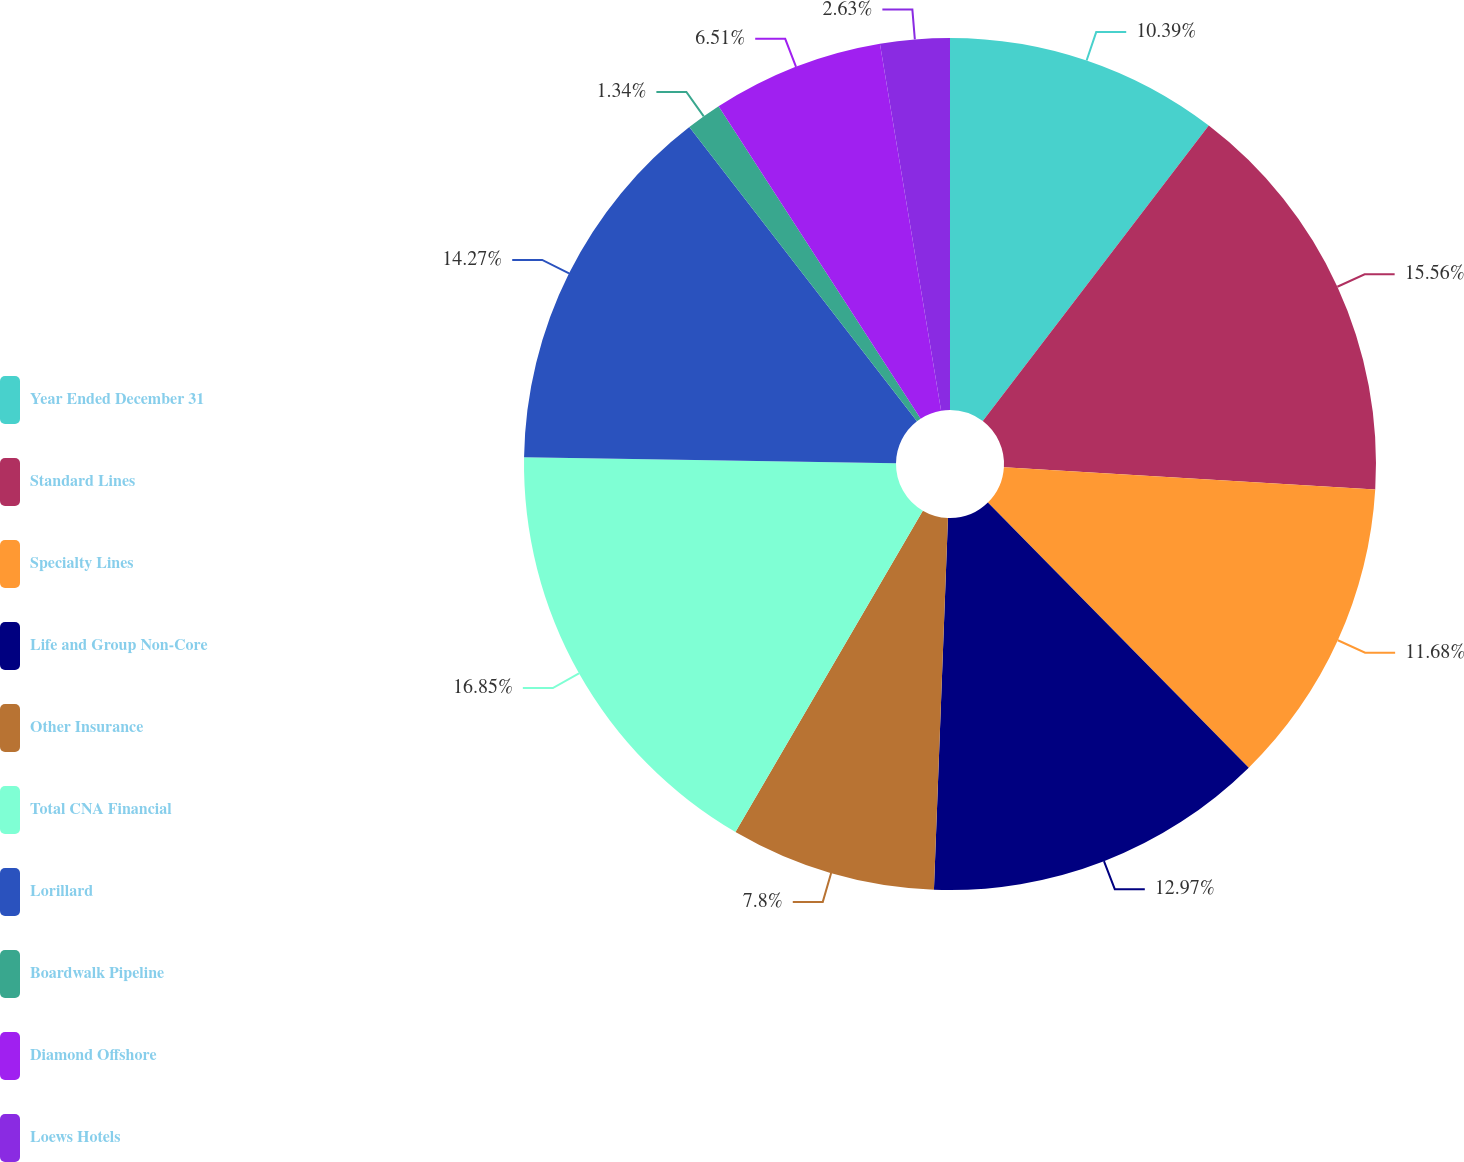Convert chart to OTSL. <chart><loc_0><loc_0><loc_500><loc_500><pie_chart><fcel>Year Ended December 31<fcel>Standard Lines<fcel>Specialty Lines<fcel>Life and Group Non-Core<fcel>Other Insurance<fcel>Total CNA Financial<fcel>Lorillard<fcel>Boardwalk Pipeline<fcel>Diamond Offshore<fcel>Loews Hotels<nl><fcel>10.39%<fcel>15.56%<fcel>11.68%<fcel>12.97%<fcel>7.8%<fcel>16.85%<fcel>14.27%<fcel>1.34%<fcel>6.51%<fcel>2.63%<nl></chart> 